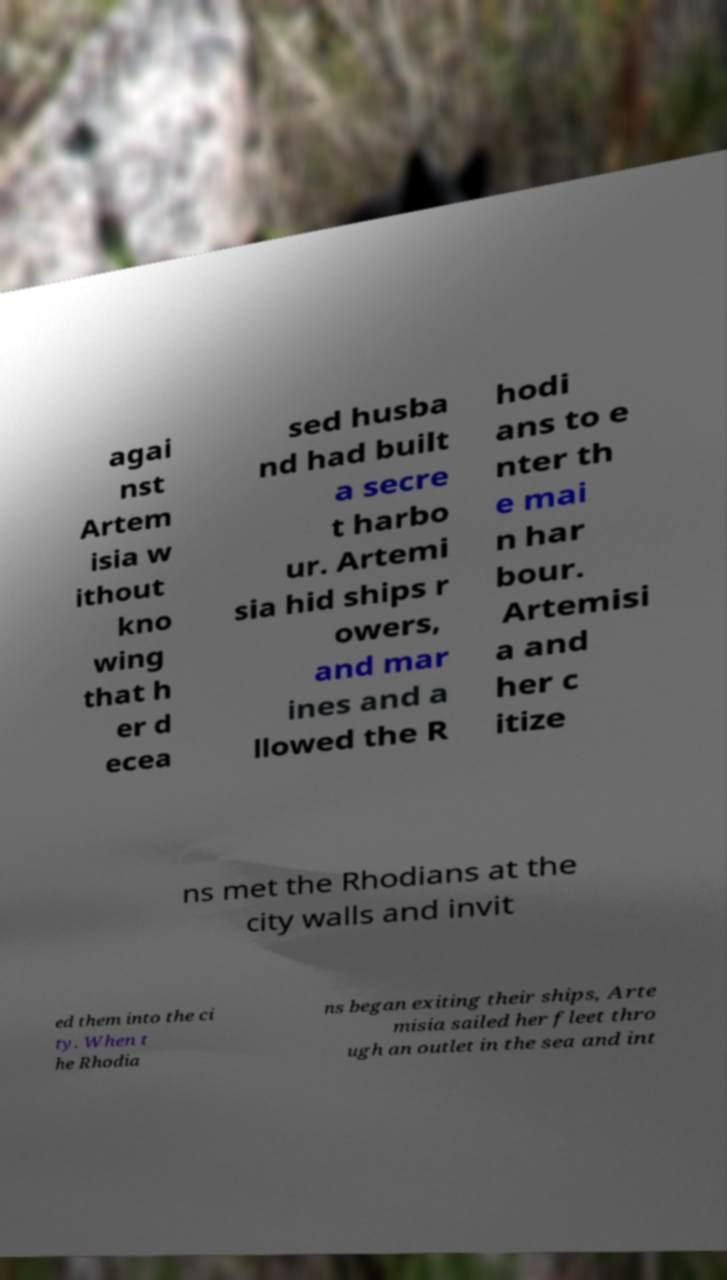Can you read and provide the text displayed in the image?This photo seems to have some interesting text. Can you extract and type it out for me? agai nst Artem isia w ithout kno wing that h er d ecea sed husba nd had built a secre t harbo ur. Artemi sia hid ships r owers, and mar ines and a llowed the R hodi ans to e nter th e mai n har bour. Artemisi a and her c itize ns met the Rhodians at the city walls and invit ed them into the ci ty. When t he Rhodia ns began exiting their ships, Arte misia sailed her fleet thro ugh an outlet in the sea and int 